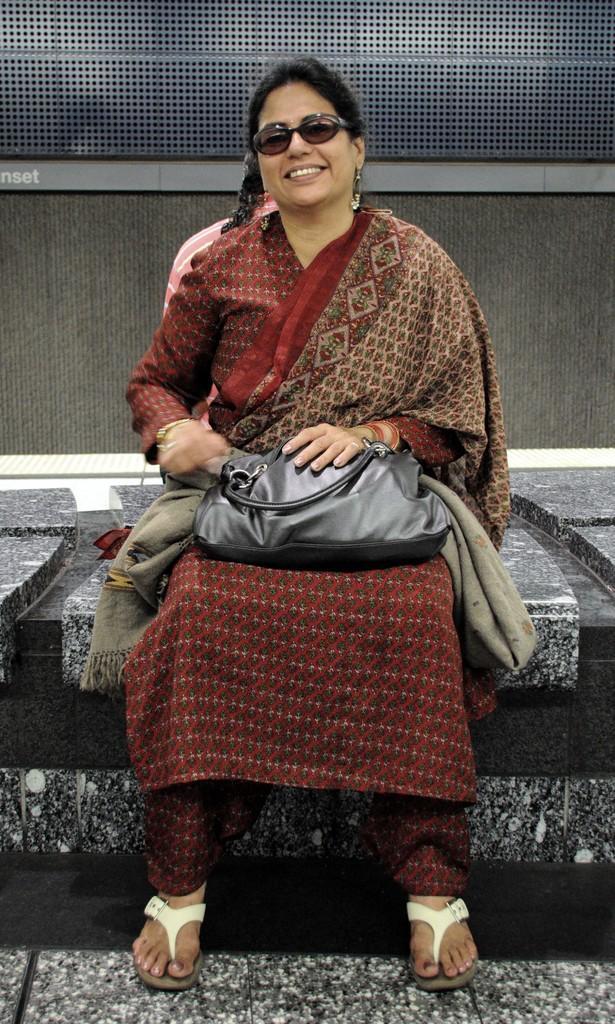Can you describe this image briefly? In the picture a woman is sitting on a bench, she is smiling, she is wearing red dress, she is carrying a black handbag. In the background there is a wall. 